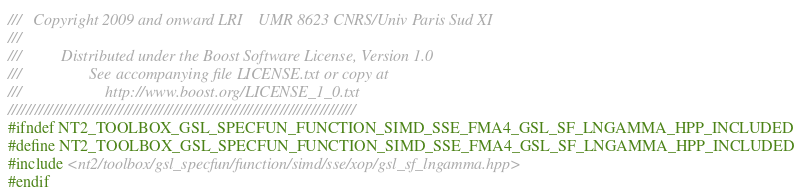<code> <loc_0><loc_0><loc_500><loc_500><_C++_>///   Copyright 2009 and onward LRI    UMR 8623 CNRS/Univ Paris Sud XI
///
///          Distributed under the Boost Software License, Version 1.0
///                 See accompanying file LICENSE.txt or copy at
///                     http://www.boost.org/LICENSE_1_0.txt
//////////////////////////////////////////////////////////////////////////////
#ifndef NT2_TOOLBOX_GSL_SPECFUN_FUNCTION_SIMD_SSE_FMA4_GSL_SF_LNGAMMA_HPP_INCLUDED
#define NT2_TOOLBOX_GSL_SPECFUN_FUNCTION_SIMD_SSE_FMA4_GSL_SF_LNGAMMA_HPP_INCLUDED
#include <nt2/toolbox/gsl_specfun/function/simd/sse/xop/gsl_sf_lngamma.hpp>
#endif
</code> 